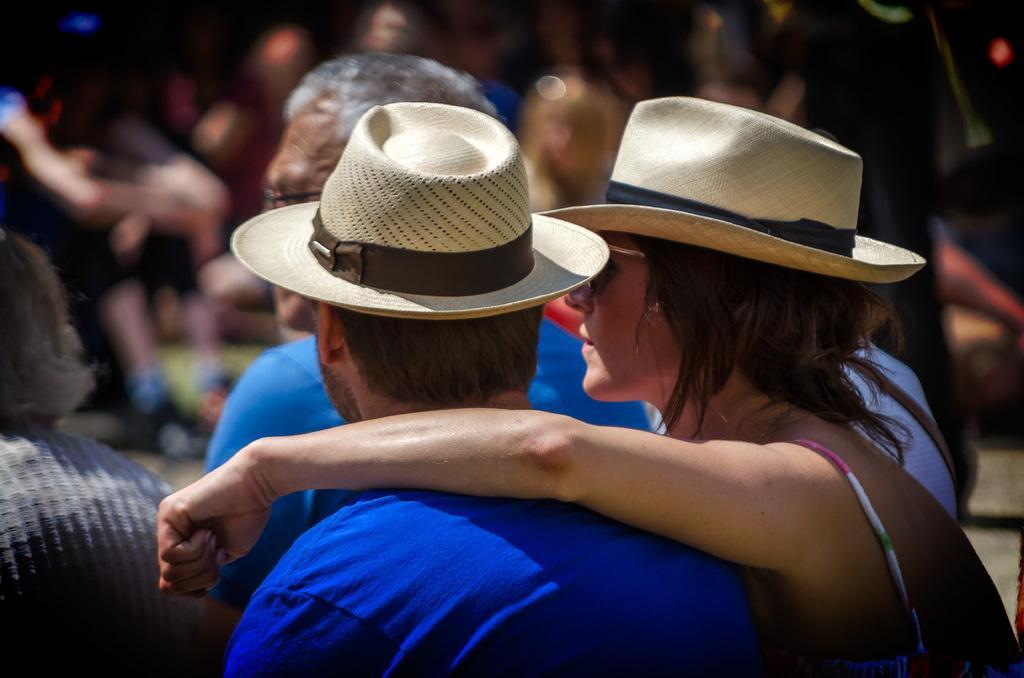Please provide a concise description of this image. In this image I can see group of people. In front the person is wearing blue shirt and cream color cap and I can see the blurred background. 